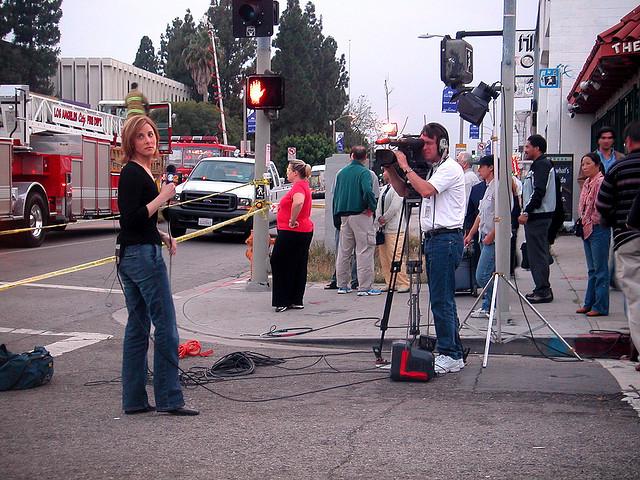What is the woman in red doing?
Keep it brief. Standing. Are there more people shown working or not working?
Give a very brief answer. Not working. What is the woman in black doing?
Concise answer only. Reporting. Who is taking a picture?
Write a very short answer. Photographer. 